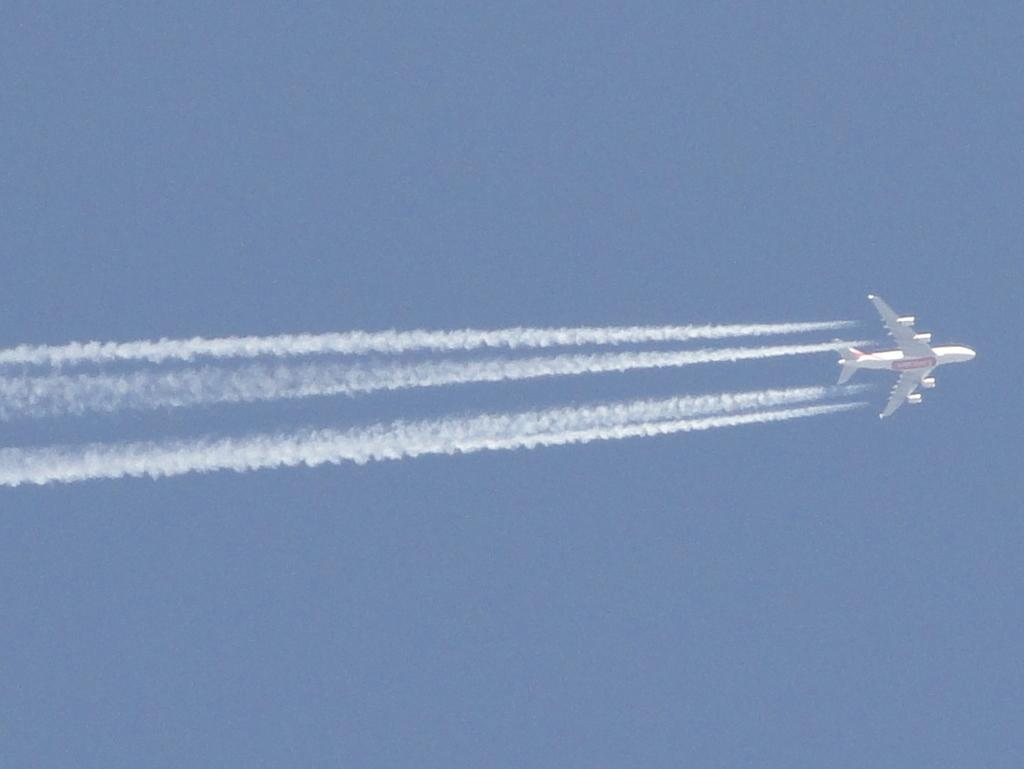What is the main subject of the image? The main subject of the image is an airplane. What is the airplane doing in the image? The airplane is flying in the sky. Can you describe the air around the airplane? There is smoke in the air. How would you describe the sky in the image? The sky is clear. Where are the ants in the image? There are no ants present in the image. Can you describe the road in the image? There is no road present in the image. What type of dock can be seen in the image? There is no dock present in the image. 